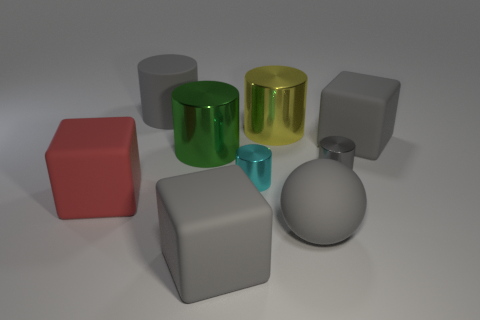There is a large sphere; does it have the same color as the large thing to the right of the gray metallic thing?
Give a very brief answer. Yes. What number of things are either big matte spheres or tiny brown things?
Provide a short and direct response. 1. Are the green cylinder and the small cylinder in front of the gray metallic object made of the same material?
Provide a short and direct response. Yes. What is the size of the gray rubber cube that is to the left of the yellow metal cylinder?
Ensure brevity in your answer.  Large. Is the number of large cubes less than the number of gray matte balls?
Your response must be concise. No. Is there a big thing that has the same color as the big rubber sphere?
Offer a very short reply. Yes. What shape is the gray matte object that is behind the gray metallic thing and right of the cyan metallic cylinder?
Your response must be concise. Cube. What shape is the shiny thing behind the big gray cube that is behind the small cyan object?
Your response must be concise. Cylinder. Does the yellow shiny thing have the same shape as the small cyan metal thing?
Keep it short and to the point. Yes. There is a tiny thing that is the same color as the large sphere; what is its material?
Offer a very short reply. Metal. 